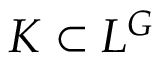<formula> <loc_0><loc_0><loc_500><loc_500>K \subset L ^ { G }</formula> 